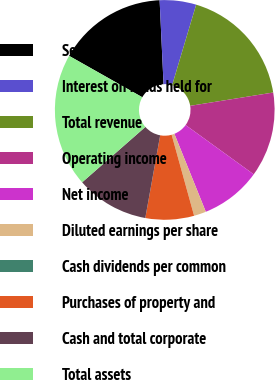<chart> <loc_0><loc_0><loc_500><loc_500><pie_chart><fcel>Service revenue<fcel>Interest on funds held for<fcel>Total revenue<fcel>Operating income<fcel>Net income<fcel>Diluted earnings per share<fcel>Cash dividends per common<fcel>Purchases of property and<fcel>Cash and total corporate<fcel>Total assets<nl><fcel>16.07%<fcel>5.36%<fcel>17.85%<fcel>12.5%<fcel>8.93%<fcel>1.79%<fcel>0.0%<fcel>7.14%<fcel>10.71%<fcel>19.64%<nl></chart> 